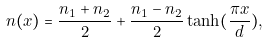<formula> <loc_0><loc_0><loc_500><loc_500>n ( x ) = \frac { n _ { 1 } + n _ { 2 } } { 2 } + \frac { n _ { 1 } - n _ { 2 } } { 2 } \tanh ( \frac { \pi x } { d } ) ,</formula> 